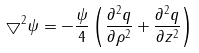Convert formula to latex. <formula><loc_0><loc_0><loc_500><loc_500>\bigtriangledown ^ { 2 } \psi = - \frac { \psi } { 4 } \left ( \frac { \partial ^ { 2 } q } { \partial \rho ^ { 2 } } + \frac { \partial ^ { 2 } q } { \partial z ^ { 2 } } \right )</formula> 